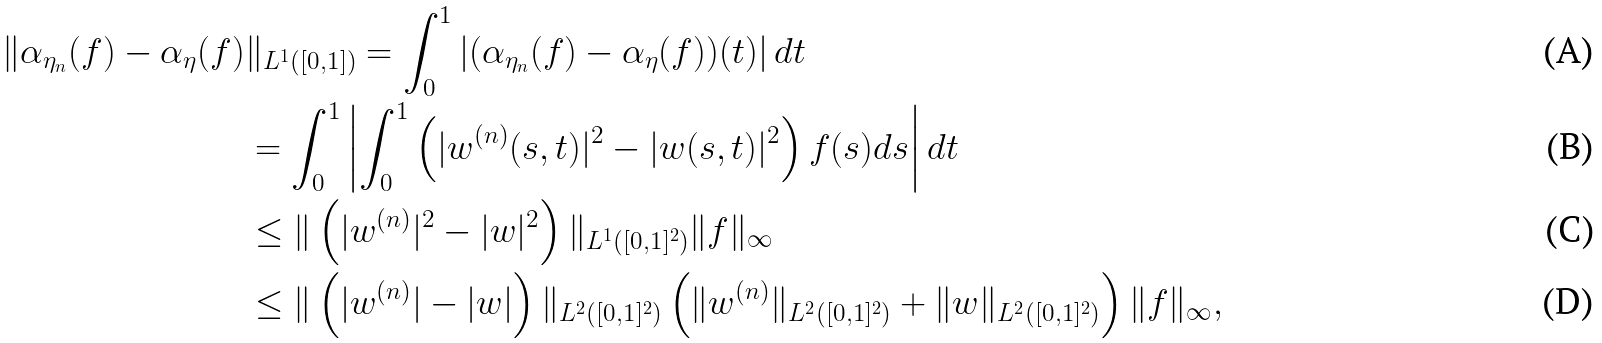Convert formula to latex. <formula><loc_0><loc_0><loc_500><loc_500>\| \alpha _ { \eta _ { n } } ( f ) - \alpha _ { \eta } ( f ) & \| _ { L ^ { 1 } ( [ 0 , 1 ] ) } = \int _ { 0 } ^ { 1 } \left | ( \alpha _ { \eta _ { n } } ( f ) - \alpha _ { \eta } ( f ) ) ( t ) \right | d t \\ & = \int _ { 0 } ^ { 1 } \left | \int _ { 0 } ^ { 1 } \left ( | w ^ { ( n ) } ( s , t ) | ^ { 2 } - | w ( s , t ) | ^ { 2 } \right ) f ( s ) d s \right | d t \\ & \leq \| \left ( | w ^ { ( n ) } | ^ { 2 } - | w | ^ { 2 } \right ) \| _ { L ^ { 1 } ( [ 0 , 1 ] ^ { 2 } ) } \| f \| _ { \infty } \\ & \leq \| \left ( | w ^ { ( n ) } | - | w | \right ) \| _ { L ^ { 2 } ( [ 0 , 1 ] ^ { 2 } ) } \left ( \| w ^ { ( n ) } \| _ { L ^ { 2 } ( [ 0 , 1 ] ^ { 2 } ) } + \| w \| _ { L ^ { 2 } ( [ 0 , 1 ] ^ { 2 } ) } \right ) \| f \| _ { \infty } ,</formula> 